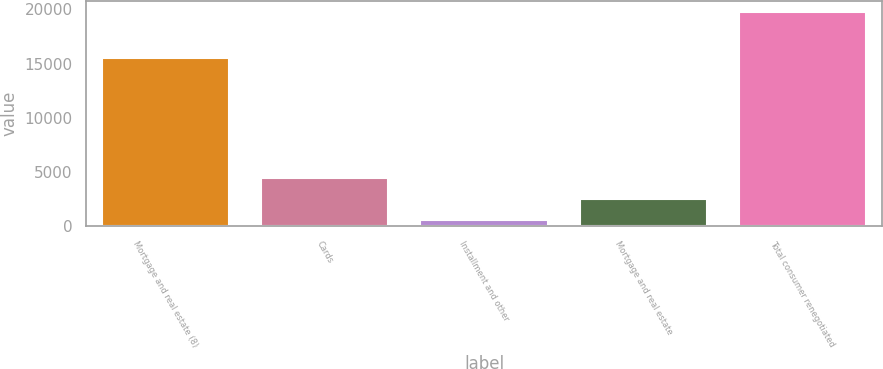Convert chart. <chart><loc_0><loc_0><loc_500><loc_500><bar_chart><fcel>Mortgage and real estate (8)<fcel>Cards<fcel>Installment and other<fcel>Mortgage and real estate<fcel>Total consumer renegotiated<nl><fcel>15514<fcel>4420.4<fcel>580<fcel>2500.2<fcel>19782<nl></chart> 